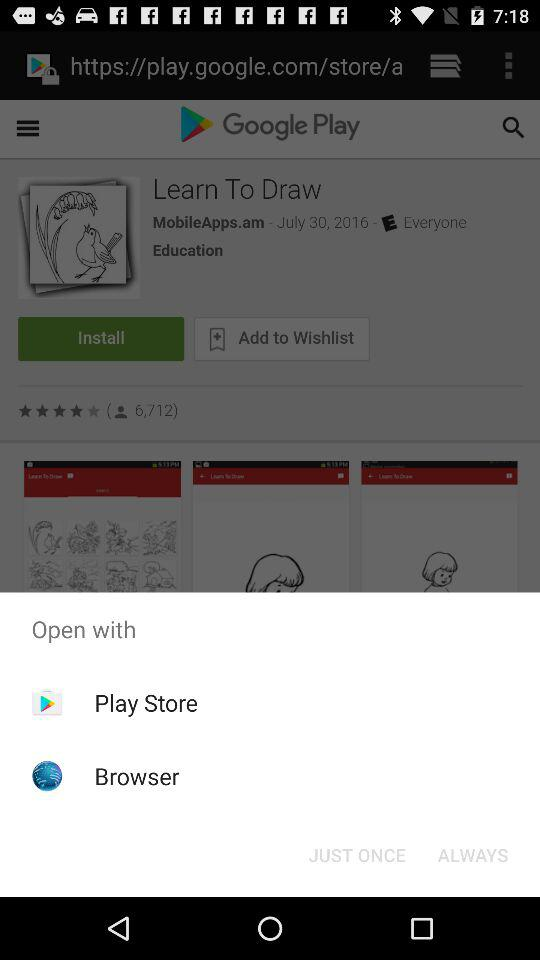What is the main application in which other application is displayed? The main application is "Learn To Draw". 